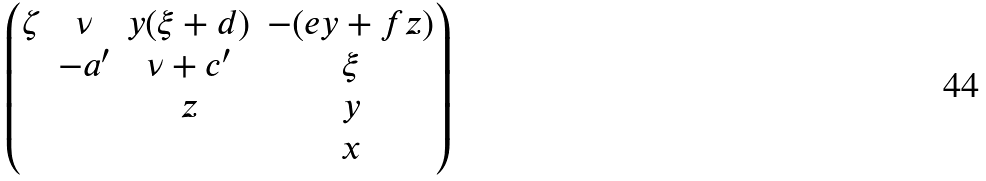<formula> <loc_0><loc_0><loc_500><loc_500>\begin{pmatrix} \zeta & \nu & y ( \xi + d ) & - ( e y + f z ) \\ & - a ^ { \prime } & \nu + c ^ { \prime } & \xi \\ & & z & y \\ & & & x \end{pmatrix}</formula> 